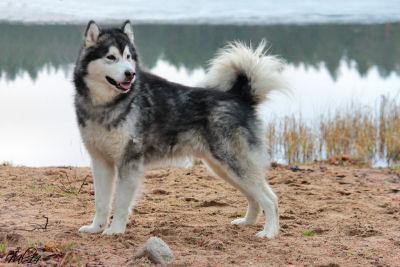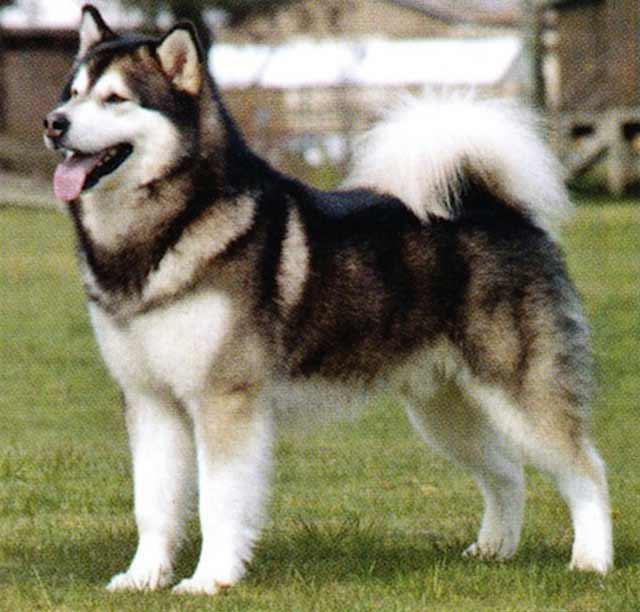The first image is the image on the left, the second image is the image on the right. Examine the images to the left and right. Is the description "There is at least one person visible behind a dog." accurate? Answer yes or no. No. 